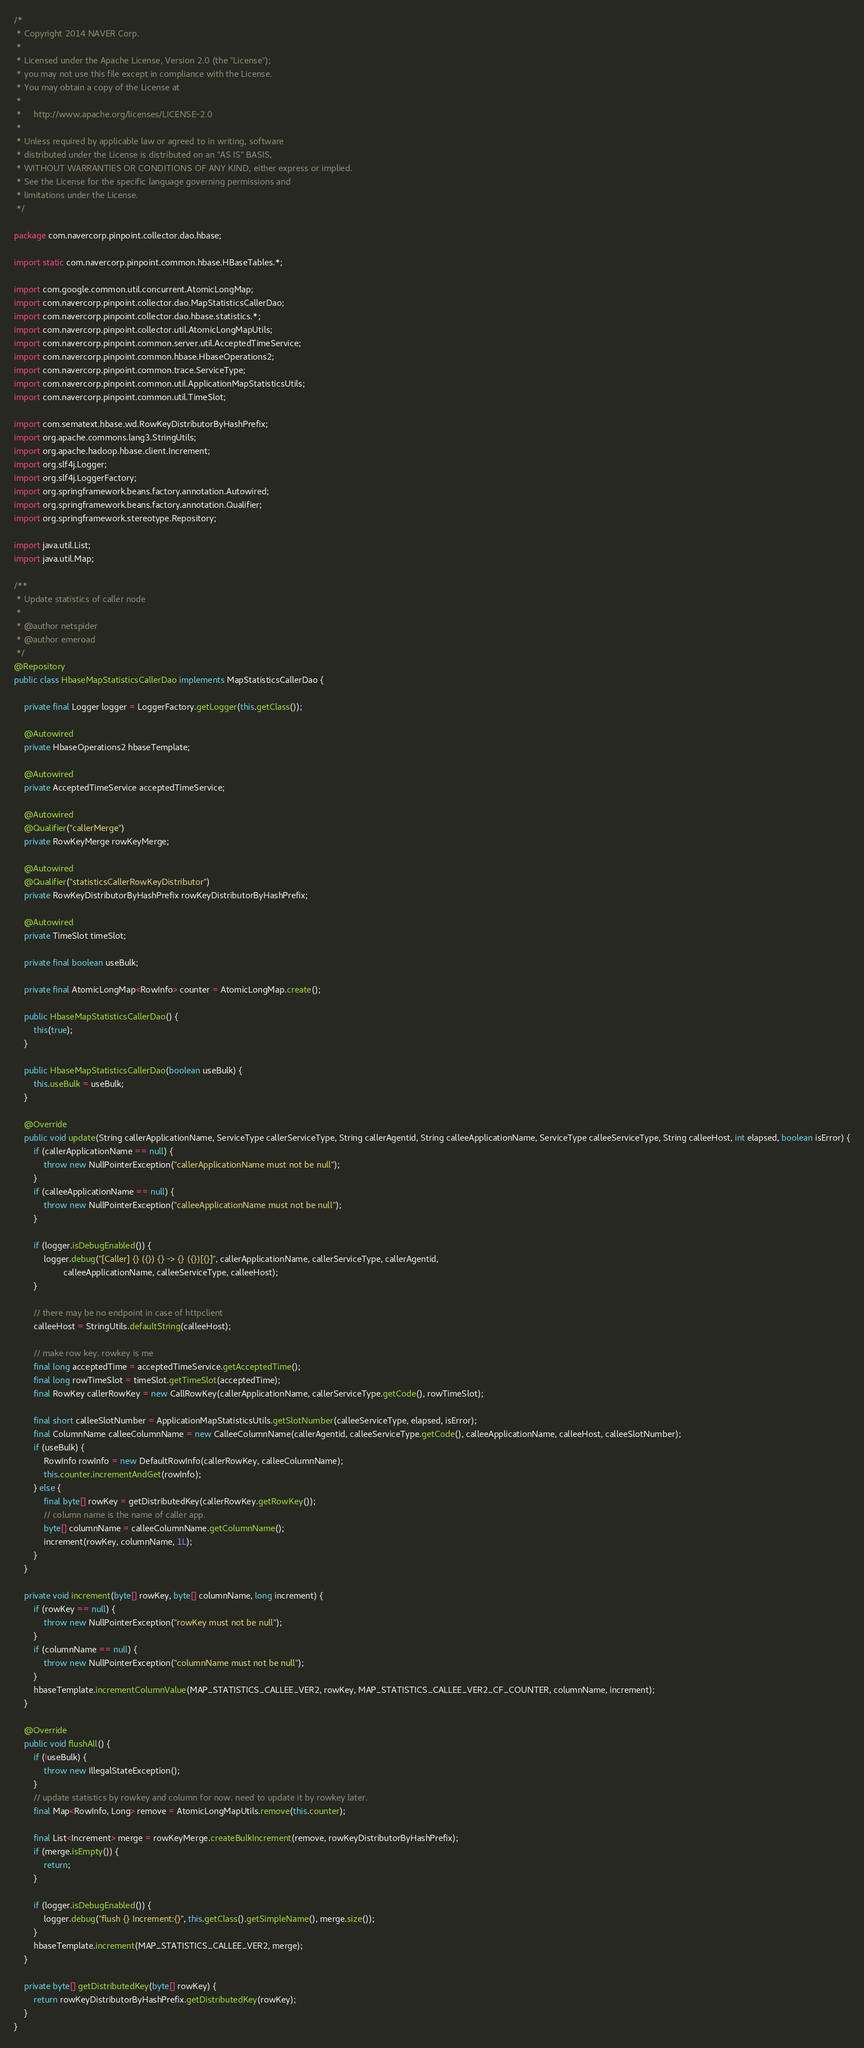<code> <loc_0><loc_0><loc_500><loc_500><_Java_>/*
 * Copyright 2014 NAVER Corp.
 *
 * Licensed under the Apache License, Version 2.0 (the "License");
 * you may not use this file except in compliance with the License.
 * You may obtain a copy of the License at
 *
 *     http://www.apache.org/licenses/LICENSE-2.0
 *
 * Unless required by applicable law or agreed to in writing, software
 * distributed under the License is distributed on an "AS IS" BASIS,
 * WITHOUT WARRANTIES OR CONDITIONS OF ANY KIND, either express or implied.
 * See the License for the specific language governing permissions and
 * limitations under the License.
 */

package com.navercorp.pinpoint.collector.dao.hbase;

import static com.navercorp.pinpoint.common.hbase.HBaseTables.*;

import com.google.common.util.concurrent.AtomicLongMap;
import com.navercorp.pinpoint.collector.dao.MapStatisticsCallerDao;
import com.navercorp.pinpoint.collector.dao.hbase.statistics.*;
import com.navercorp.pinpoint.collector.util.AtomicLongMapUtils;
import com.navercorp.pinpoint.common.server.util.AcceptedTimeService;
import com.navercorp.pinpoint.common.hbase.HbaseOperations2;
import com.navercorp.pinpoint.common.trace.ServiceType;
import com.navercorp.pinpoint.common.util.ApplicationMapStatisticsUtils;
import com.navercorp.pinpoint.common.util.TimeSlot;

import com.sematext.hbase.wd.RowKeyDistributorByHashPrefix;
import org.apache.commons.lang3.StringUtils;
import org.apache.hadoop.hbase.client.Increment;
import org.slf4j.Logger;
import org.slf4j.LoggerFactory;
import org.springframework.beans.factory.annotation.Autowired;
import org.springframework.beans.factory.annotation.Qualifier;
import org.springframework.stereotype.Repository;

import java.util.List;
import java.util.Map;

/**
 * Update statistics of caller node
 * 
 * @author netspider
 * @author emeroad
 */
@Repository
public class HbaseMapStatisticsCallerDao implements MapStatisticsCallerDao {

    private final Logger logger = LoggerFactory.getLogger(this.getClass());

    @Autowired
    private HbaseOperations2 hbaseTemplate;

    @Autowired
    private AcceptedTimeService acceptedTimeService;

    @Autowired
    @Qualifier("callerMerge")
    private RowKeyMerge rowKeyMerge;

    @Autowired
    @Qualifier("statisticsCallerRowKeyDistributor")
    private RowKeyDistributorByHashPrefix rowKeyDistributorByHashPrefix;

    @Autowired
    private TimeSlot timeSlot;

    private final boolean useBulk;

    private final AtomicLongMap<RowInfo> counter = AtomicLongMap.create();

    public HbaseMapStatisticsCallerDao() {
        this(true);
    }

    public HbaseMapStatisticsCallerDao(boolean useBulk) {
        this.useBulk = useBulk;
    }

    @Override
    public void update(String callerApplicationName, ServiceType callerServiceType, String callerAgentid, String calleeApplicationName, ServiceType calleeServiceType, String calleeHost, int elapsed, boolean isError) {
        if (callerApplicationName == null) {
            throw new NullPointerException("callerApplicationName must not be null");
        }
        if (calleeApplicationName == null) {
            throw new NullPointerException("calleeApplicationName must not be null");
        }

        if (logger.isDebugEnabled()) {
            logger.debug("[Caller] {} ({}) {} -> {} ({})[{}]", callerApplicationName, callerServiceType, callerAgentid,
                    calleeApplicationName, calleeServiceType, calleeHost);
        }

        // there may be no endpoint in case of httpclient
        calleeHost = StringUtils.defaultString(calleeHost);

        // make row key. rowkey is me
        final long acceptedTime = acceptedTimeService.getAcceptedTime();
        final long rowTimeSlot = timeSlot.getTimeSlot(acceptedTime);
        final RowKey callerRowKey = new CallRowKey(callerApplicationName, callerServiceType.getCode(), rowTimeSlot);

        final short calleeSlotNumber = ApplicationMapStatisticsUtils.getSlotNumber(calleeServiceType, elapsed, isError);
        final ColumnName calleeColumnName = new CalleeColumnName(callerAgentid, calleeServiceType.getCode(), calleeApplicationName, calleeHost, calleeSlotNumber);
        if (useBulk) {
            RowInfo rowInfo = new DefaultRowInfo(callerRowKey, calleeColumnName);
            this.counter.incrementAndGet(rowInfo);
        } else {
            final byte[] rowKey = getDistributedKey(callerRowKey.getRowKey());
            // column name is the name of caller app.
            byte[] columnName = calleeColumnName.getColumnName();
            increment(rowKey, columnName, 1L);
        }
    }

    private void increment(byte[] rowKey, byte[] columnName, long increment) {
        if (rowKey == null) {
            throw new NullPointerException("rowKey must not be null");
        }
        if (columnName == null) {
            throw new NullPointerException("columnName must not be null");
        }
        hbaseTemplate.incrementColumnValue(MAP_STATISTICS_CALLEE_VER2, rowKey, MAP_STATISTICS_CALLEE_VER2_CF_COUNTER, columnName, increment);
    }

    @Override
    public void flushAll() {
        if (!useBulk) {
            throw new IllegalStateException();
        }
        // update statistics by rowkey and column for now. need to update it by rowkey later.
        final Map<RowInfo, Long> remove = AtomicLongMapUtils.remove(this.counter);

        final List<Increment> merge = rowKeyMerge.createBulkIncrement(remove, rowKeyDistributorByHashPrefix);
        if (merge.isEmpty()) {
            return;
        }

        if (logger.isDebugEnabled()) {
            logger.debug("flush {} Increment:{}", this.getClass().getSimpleName(), merge.size());
        }
        hbaseTemplate.increment(MAP_STATISTICS_CALLEE_VER2, merge);
    }

    private byte[] getDistributedKey(byte[] rowKey) {
        return rowKeyDistributorByHashPrefix.getDistributedKey(rowKey);
    }
}</code> 